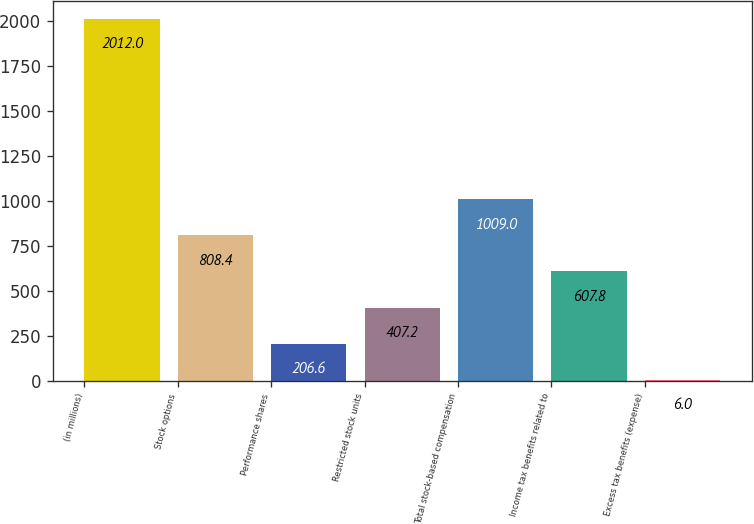Convert chart to OTSL. <chart><loc_0><loc_0><loc_500><loc_500><bar_chart><fcel>(in millions)<fcel>Stock options<fcel>Performance shares<fcel>Restricted stock units<fcel>Total stock-based compensation<fcel>Income tax benefits related to<fcel>Excess tax benefits (expense)<nl><fcel>2012<fcel>808.4<fcel>206.6<fcel>407.2<fcel>1009<fcel>607.8<fcel>6<nl></chart> 